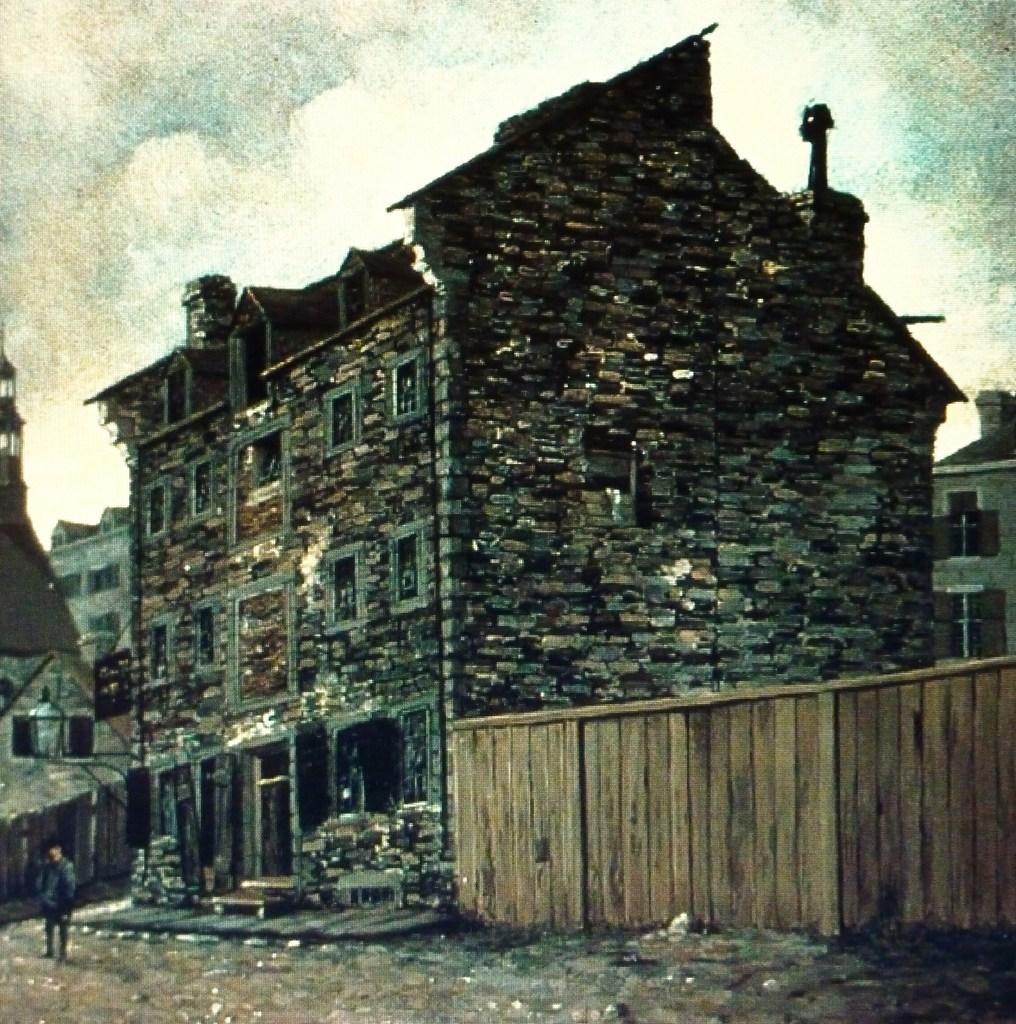In one or two sentences, can you explain what this image depicts? In this image, we can the painting of a building and a fencing and there is also a person. 